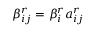Convert formula to latex. <formula><loc_0><loc_0><loc_500><loc_500>\beta _ { i j } ^ { r } = \beta _ { i } ^ { r } a _ { i j } ^ { r }</formula> 